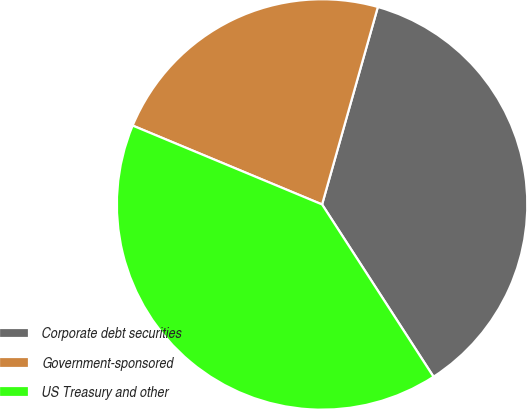Convert chart. <chart><loc_0><loc_0><loc_500><loc_500><pie_chart><fcel>Corporate debt securities<fcel>Government-sponsored<fcel>US Treasury and other<nl><fcel>36.48%<fcel>23.1%<fcel>40.42%<nl></chart> 